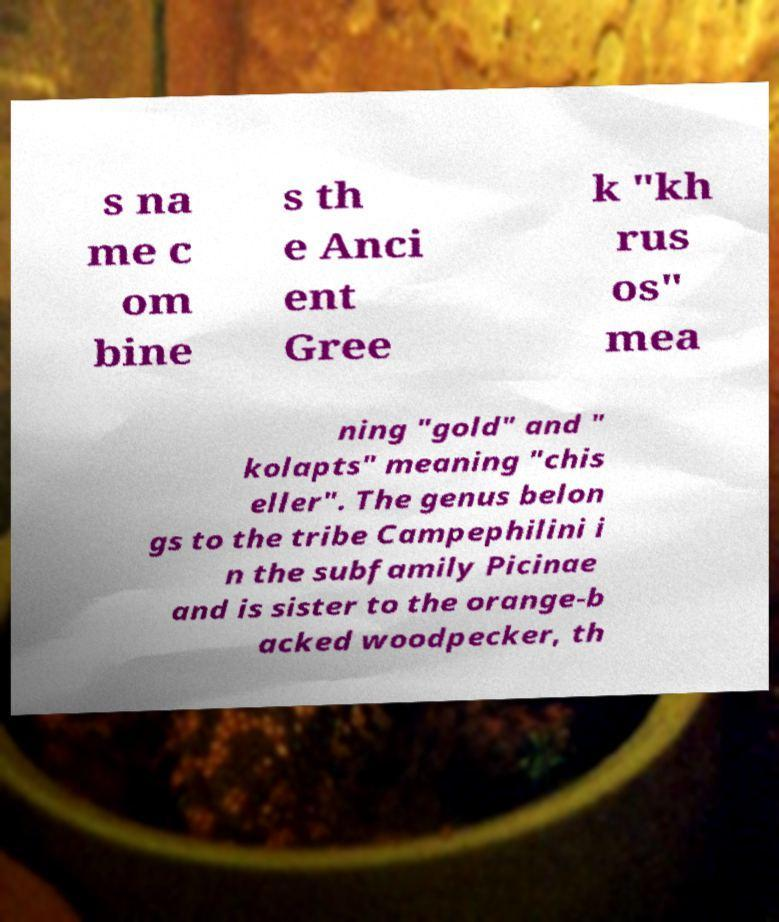Could you extract and type out the text from this image? s na me c om bine s th e Anci ent Gree k "kh rus os" mea ning "gold" and " kolapts" meaning "chis eller". The genus belon gs to the tribe Campephilini i n the subfamily Picinae and is sister to the orange-b acked woodpecker, th 